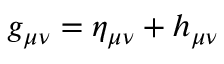<formula> <loc_0><loc_0><loc_500><loc_500>g _ { \mu \nu } = \eta _ { \mu \nu } + h _ { \mu \nu }</formula> 